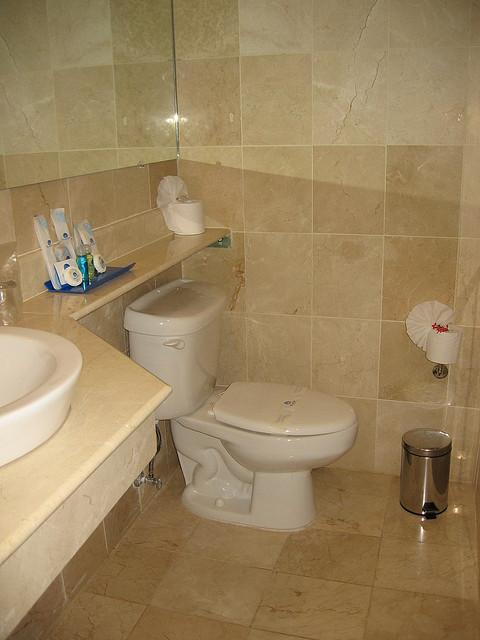Where is this bathroom located? Please explain your reasoning. hotel. From the products, that's where it looks like it's from. 